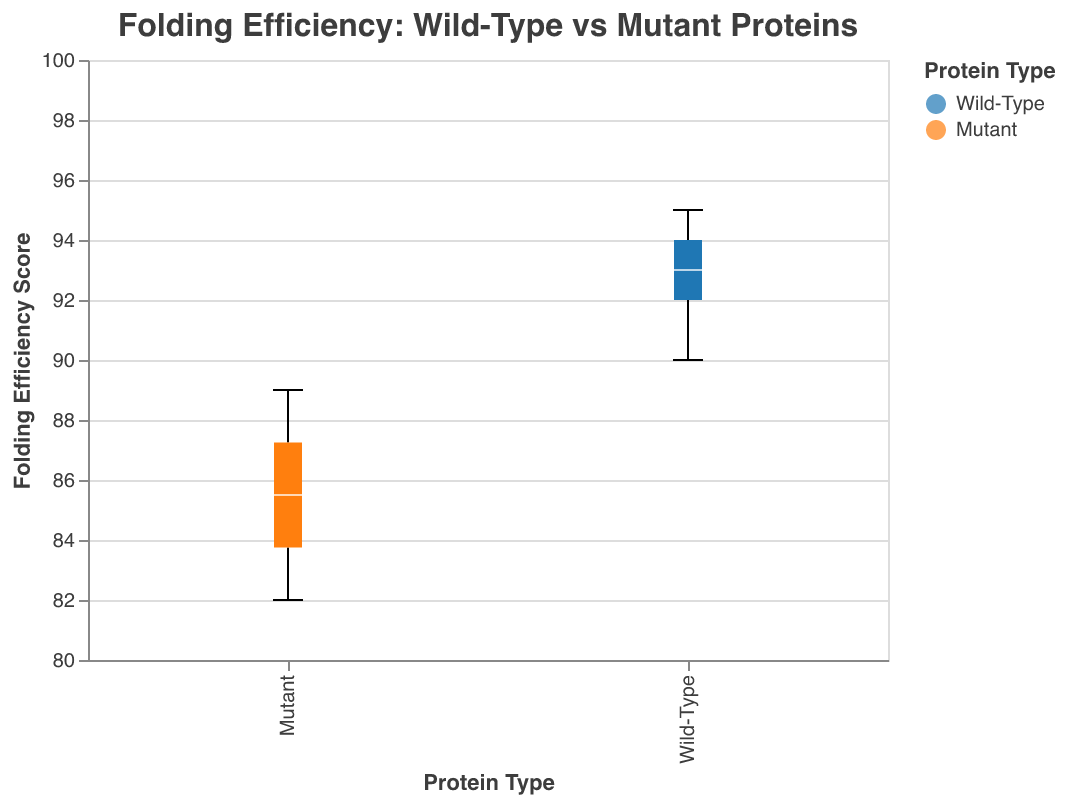What is the title of the figure? The title is usually located at the top of the figure and is used to provide a summary of what the plot represents. Here, it reads “Folding Efficiency: Wild-Type vs Mutant Proteins”.
Answer: Folding Efficiency: Wild-Type vs Mutant Proteins What are the two categories compared in the figure? The x-axis shows the categories, which are “Wild-Type” and “Mutant”. These categories are also indicated by different colors in the plot, blue for Wild-Type and orange for Mutant.
Answer: Wild-Type and Mutant What is the color scheme used to differentiate between Wild-Type and Mutant proteins? The legend and the colors of the boxplots show that Wild-Type proteins are represented in blue, while Mutant proteins are shown in orange.
Answer: Blue for Wild-Type, Orange for Mutant What range of folding efficiency scores is depicted on the y-axis? The y-axis scale shows the range of folding efficiency scores, which spans from 80 to 100.
Answer: 80 to 100 What is the median folding efficiency score for Wild-Type proteins? In a box plot, the median is indicated by the line inside the box. For the Wild-Type proteins, the median line falls at 93.
Answer: 93 Which group, Wild-Type or Mutant, has a higher median folding efficiency score? By comparing the median lines of both boxplots, it's clear that the median folding efficiency score of Wild-Type proteins (93) is higher than that of Mutant proteins (86.5).
Answer: Wild-Type How does the range (spread) of folding efficiency scores for Wild-Type proteins compare to that of Mutant proteins? Examining the extent of both boxplots, Wild-Type proteins have a range from 90 to 95, whereas Mutant proteins have a broader range from 82 to 89.
Answer: Wild-Type: 90-95, Mutant: 82-89 Do any of the mutant proteins have a folding efficiency score higher than the lowest Wild-Type protein? The lowest folding efficiency score for Wild-Type proteins is 90, and the highest score for Mutant proteins is 89. Hence, no mutant protein has a score higher than the lowest Wild-Type protein.
Answer: No Is there any overlap in the interquartile ranges of Wild-Type and Mutant proteins? The interquartile range (IQR) is the range covered by the box in the boxplot. The IQR for Wild-Type is from 92 to 94, and for Mutant, it is from 84 to 88. Since these intervals do not overlap, there is no overlap in the IQRs.
Answer: No Given the notches in the box plot, is there a significant difference between the median folding efficiencies of Wild-Type and Mutant proteins? The notches in the box plot help in evaluating if medians are significantly different. If the notches of two boxes do not overlap, it suggests a significant difference between medians. Here, the notches do not overlap between Wild-Type and Mutant proteins, indicating a significant difference.
Answer: Yes 